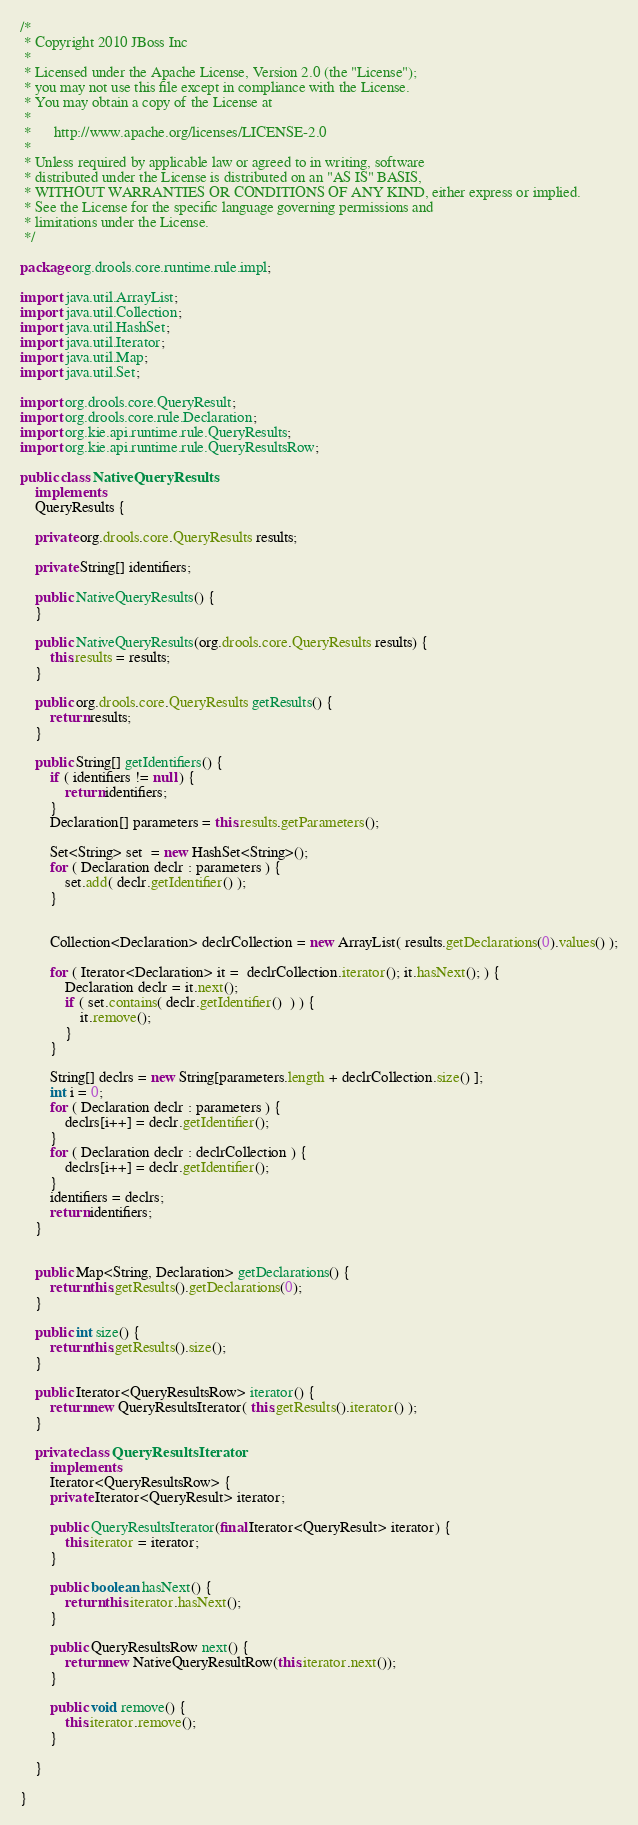Convert code to text. <code><loc_0><loc_0><loc_500><loc_500><_Java_>/*
 * Copyright 2010 JBoss Inc
 *
 * Licensed under the Apache License, Version 2.0 (the "License");
 * you may not use this file except in compliance with the License.
 * You may obtain a copy of the License at
 *
 *      http://www.apache.org/licenses/LICENSE-2.0
 *
 * Unless required by applicable law or agreed to in writing, software
 * distributed under the License is distributed on an "AS IS" BASIS,
 * WITHOUT WARRANTIES OR CONDITIONS OF ANY KIND, either express or implied.
 * See the License for the specific language governing permissions and
 * limitations under the License.
 */

package org.drools.core.runtime.rule.impl;

import java.util.ArrayList;
import java.util.Collection;
import java.util.HashSet;
import java.util.Iterator;
import java.util.Map;
import java.util.Set;

import org.drools.core.QueryResult;
import org.drools.core.rule.Declaration;
import org.kie.api.runtime.rule.QueryResults;
import org.kie.api.runtime.rule.QueryResultsRow;

public class NativeQueryResults
    implements
    QueryResults {
    
    private org.drools.core.QueryResults results;
    
    private String[] identifiers;
    
    public NativeQueryResults() {
    }

    public NativeQueryResults(org.drools.core.QueryResults results) {
        this.results = results;
    }

    public org.drools.core.QueryResults getResults() {
        return results;
    }

    public String[] getIdentifiers() {
        if ( identifiers != null ) {
            return identifiers;
        }
        Declaration[] parameters = this.results.getParameters();
        
        Set<String> set  = new HashSet<String>();
        for ( Declaration declr : parameters ) {
            set.add( declr.getIdentifier() );
        }
        
        
        Collection<Declaration> declrCollection = new ArrayList( results.getDeclarations(0).values() );
        
        for ( Iterator<Declaration> it =  declrCollection.iterator(); it.hasNext(); ) {
            Declaration declr = it.next();
            if ( set.contains( declr.getIdentifier()  ) ) {
                it.remove();
            }
        }   
        
        String[] declrs = new String[parameters.length + declrCollection.size() ];
        int i = 0;
        for ( Declaration declr : parameters ) {
            declrs[i++] = declr.getIdentifier();
        }
        for ( Declaration declr : declrCollection ) {
            declrs[i++] = declr.getIdentifier();
        }       
        identifiers = declrs;
        return identifiers;
    }
    
    
    public Map<String, Declaration> getDeclarations() {
        return this.getResults().getDeclarations(0);
    }

    public int size() {
        return this.getResults().size();
    }
    
    public Iterator<QueryResultsRow> iterator() {
        return new QueryResultsIterator( this.getResults().iterator() );
    }

    private class QueryResultsIterator
        implements
        Iterator<QueryResultsRow> {
        private Iterator<QueryResult> iterator;

        public QueryResultsIterator(final Iterator<QueryResult> iterator) {
            this.iterator = iterator;
        }

        public boolean hasNext() {
            return this.iterator.hasNext();
        }

        public QueryResultsRow next() {
            return new NativeQueryResultRow(this.iterator.next());
        }

        public void remove() {
            this.iterator.remove();
        }

    }

}
</code> 